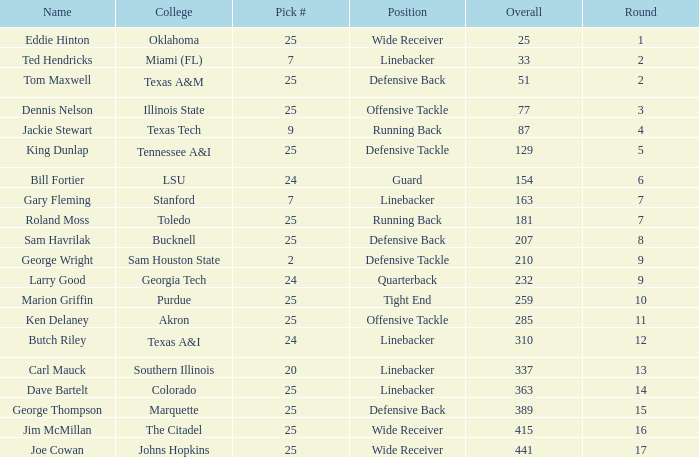Round larger than 6, and a Pick # smaller than 25, and a College of southern Illinois has what position? Linebacker. 